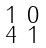<formula> <loc_0><loc_0><loc_500><loc_500>\begin{smallmatrix} 1 & 0 \\ 4 & 1 \end{smallmatrix}</formula> 